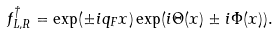Convert formula to latex. <formula><loc_0><loc_0><loc_500><loc_500>f ^ { \dagger } _ { L , R } = \exp ( \pm i q _ { F } x ) \exp ( i \Theta ( x ) \pm i \Phi ( x ) ) .</formula> 